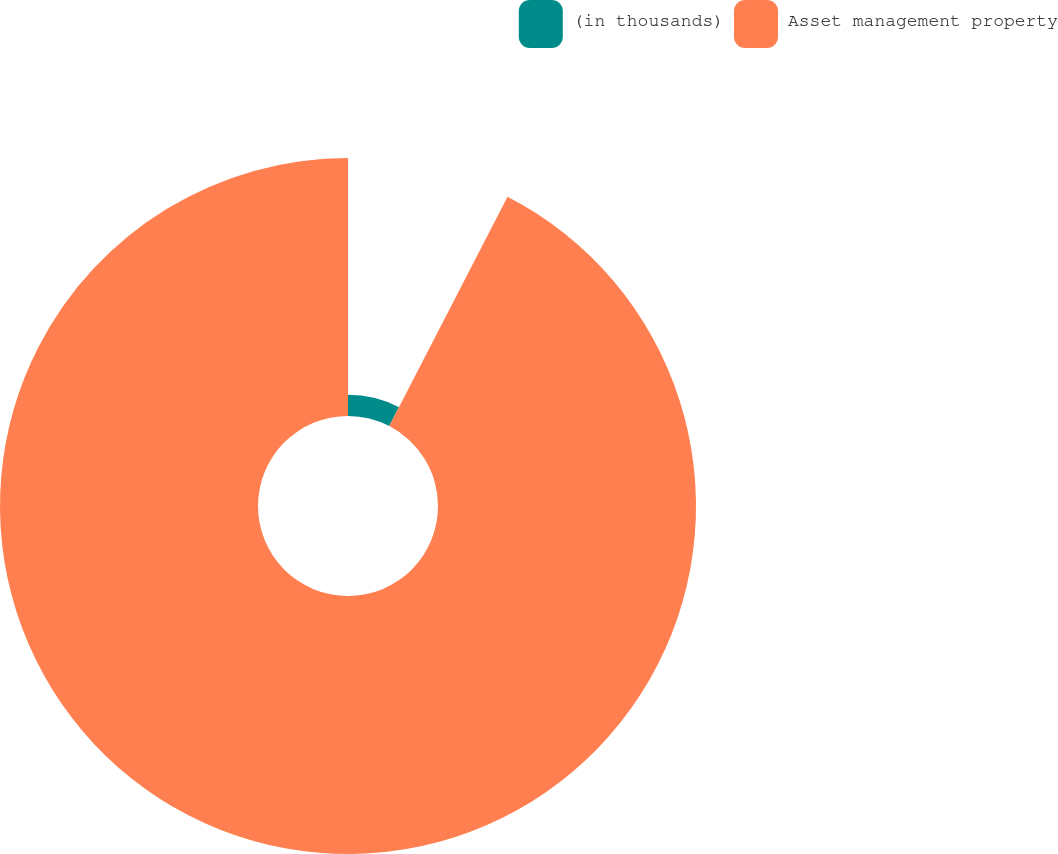<chart> <loc_0><loc_0><loc_500><loc_500><pie_chart><fcel>(in thousands)<fcel>Asset management property<nl><fcel>7.58%<fcel>92.42%<nl></chart> 